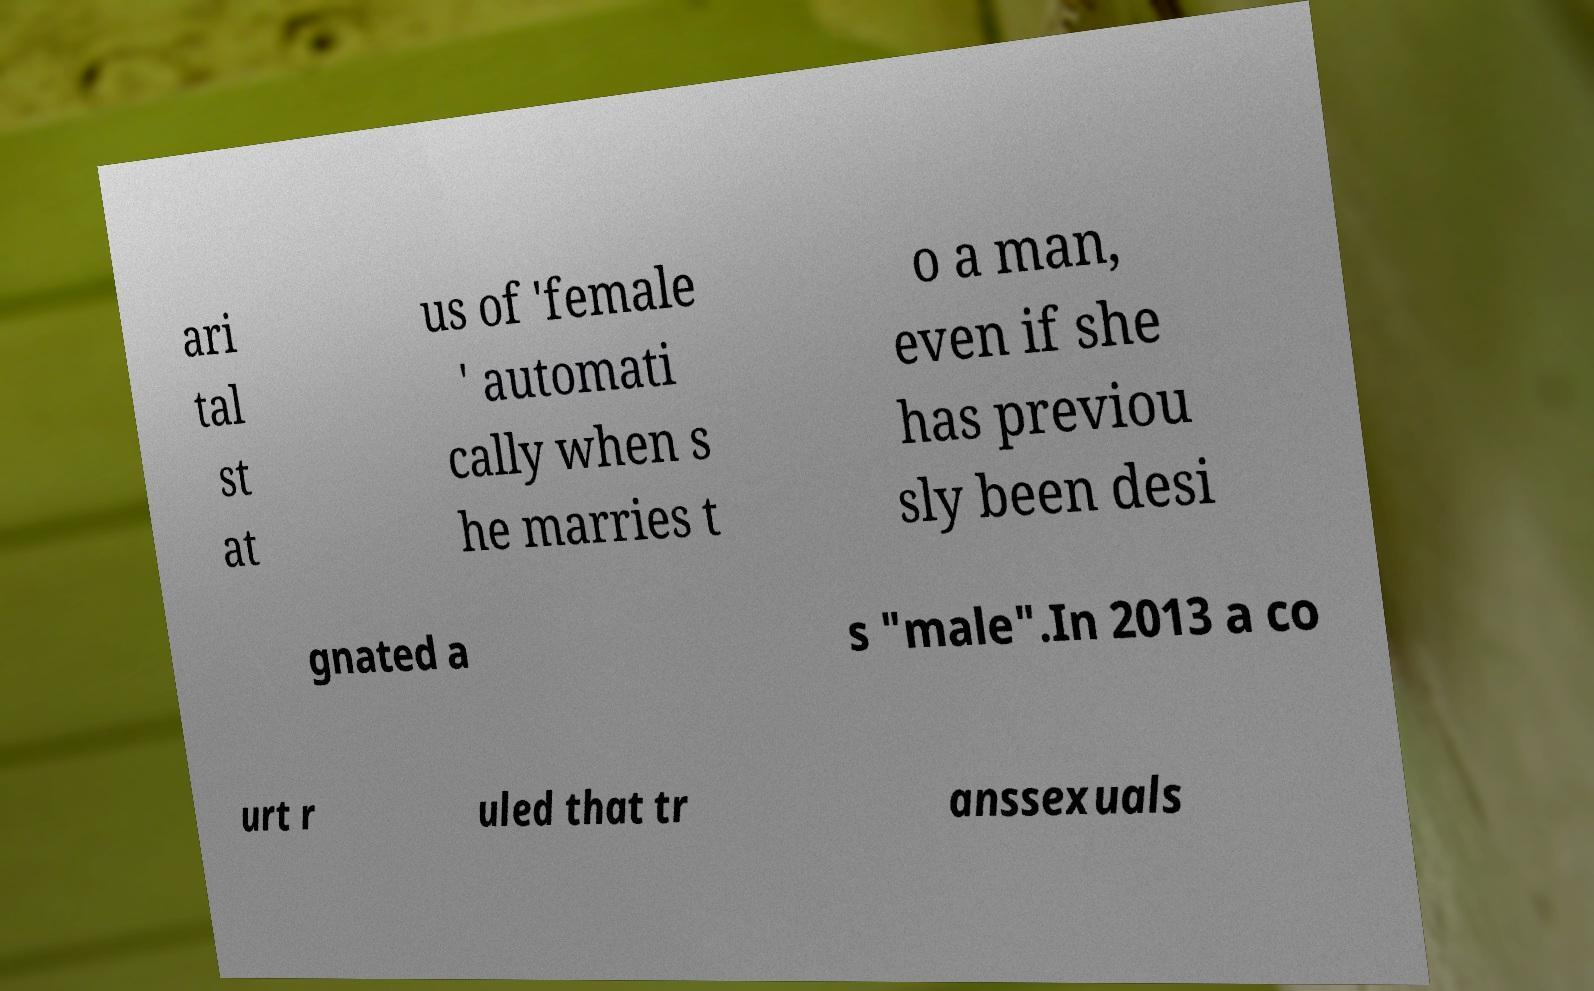What messages or text are displayed in this image? I need them in a readable, typed format. ari tal st at us of 'female ' automati cally when s he marries t o a man, even if she has previou sly been desi gnated a s "male".In 2013 a co urt r uled that tr anssexuals 